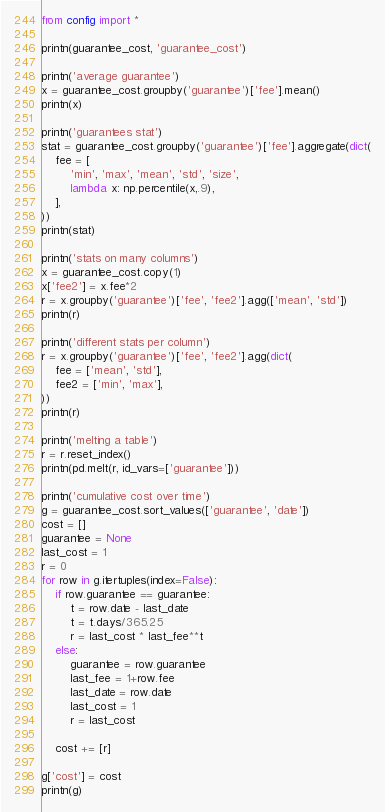<code> <loc_0><loc_0><loc_500><loc_500><_Python_>from config import *

printn(guarantee_cost, 'guarantee_cost')

printn('average guarantee')
x = guarantee_cost.groupby('guarantee')['fee'].mean()
printn(x)

printn('guarantees stat')
stat = guarantee_cost.groupby('guarantee')['fee'].aggregate(dict(
	fee = [
		'min', 'max', 'mean', 'std', 'size',
		lambda x: np.percentile(x,.9),
	],
))
printn(stat)

printn('stats on many columns')
x = guarantee_cost.copy(1)
x['fee2'] = x.fee*2
r = x.groupby('guarantee')['fee', 'fee2'].agg(['mean', 'std'])
printn(r)

printn('different stats per column')
r = x.groupby('guarantee')['fee', 'fee2'].agg(dict(
	fee = ['mean', 'std'],
	fee2 = ['min', 'max'],
))
printn(r)

printn('melting a table')
r = r.reset_index()
printn(pd.melt(r, id_vars=['guarantee'])) 

printn('cumulative cost over time')
g = guarantee_cost.sort_values(['guarantee', 'date'])
cost = []
guarantee = None
last_cost = 1
r = 0
for row in g.itertuples(index=False):
	if row.guarantee == guarantee:
		t = row.date - last_date
		t = t.days/365.25
		r = last_cost * last_fee**t
	else:
		guarantee = row.guarantee
		last_fee = 1+row.fee
		last_date = row.date
		last_cost = 1
		r = last_cost

	cost += [r]

g['cost'] = cost
printn(g)

</code> 